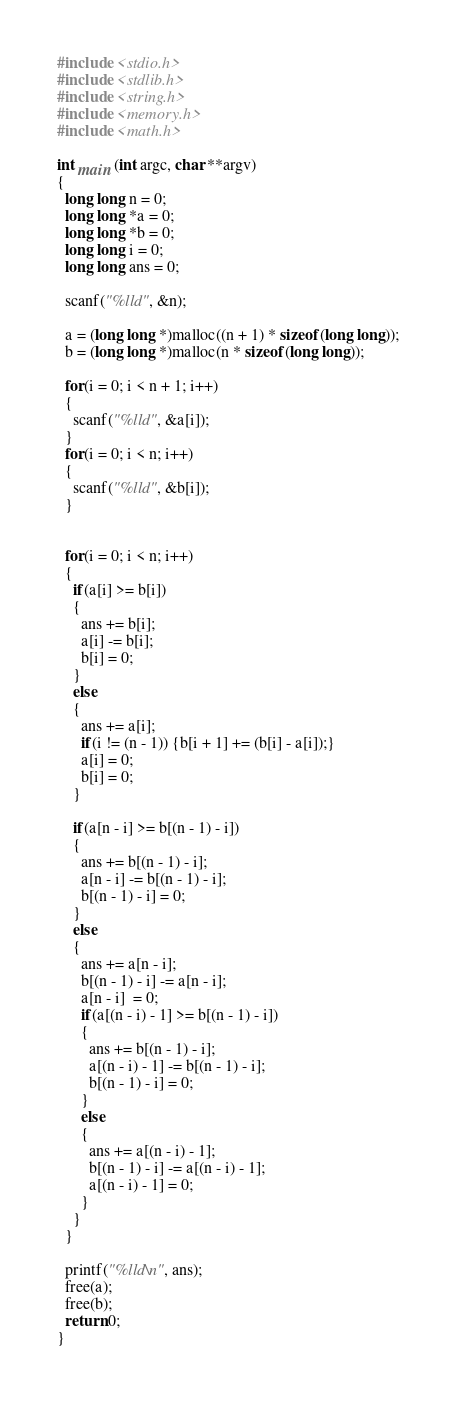<code> <loc_0><loc_0><loc_500><loc_500><_C_>#include <stdio.h>
#include <stdlib.h>
#include <string.h>
#include <memory.h>
#include <math.h>

int main (int argc, char **argv)
{
  long long n = 0;
  long long *a = 0;
  long long *b = 0;
  long long i = 0;
  long long ans = 0;

  scanf("%lld", &n);

  a = (long long *)malloc((n + 1) * sizeof(long long));
  b = (long long *)malloc(n * sizeof(long long));

  for(i = 0; i < n + 1; i++)
  {
    scanf("%lld", &a[i]);
  }
  for(i = 0; i < n; i++)
  {
    scanf("%lld", &b[i]);
  }


  for(i = 0; i < n; i++)
  {
    if(a[i] >= b[i])
    {
      ans += b[i];
      a[i] -= b[i];
      b[i] = 0;
    }
    else
    {
      ans += a[i];
      if(i != (n - 1)) {b[i + 1] += (b[i] - a[i]);}
      a[i] = 0;
      b[i] = 0;
    }

    if(a[n - i] >= b[(n - 1) - i])
    {
      ans += b[(n - 1) - i];
      a[n - i] -= b[(n - 1) - i];
      b[(n - 1) - i] = 0;
    }
    else
    {
      ans += a[n - i];
      b[(n - 1) - i] -= a[n - i];
      a[n - i]  = 0;
      if(a[(n - i) - 1] >= b[(n - 1) - i])
      {
        ans += b[(n - 1) - i];
        a[(n - i) - 1] -= b[(n - 1) - i];
        b[(n - 1) - i] = 0;
      }
      else
      {
        ans += a[(n - i) - 1];
        b[(n - 1) - i] -= a[(n - i) - 1];
        a[(n - i) - 1] = 0;
      }
    }
  }

  printf("%lld\n", ans);
  free(a);
  free(b);
  return 0;
}
</code> 